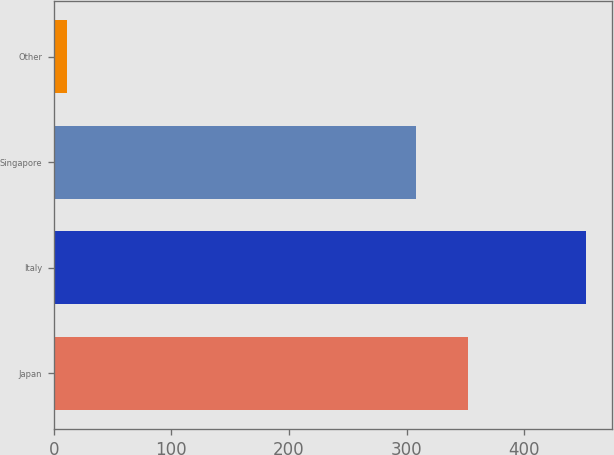Convert chart to OTSL. <chart><loc_0><loc_0><loc_500><loc_500><bar_chart><fcel>Japan<fcel>Italy<fcel>Singapore<fcel>Other<nl><fcel>352.17<fcel>452.3<fcel>308.1<fcel>11.6<nl></chart> 